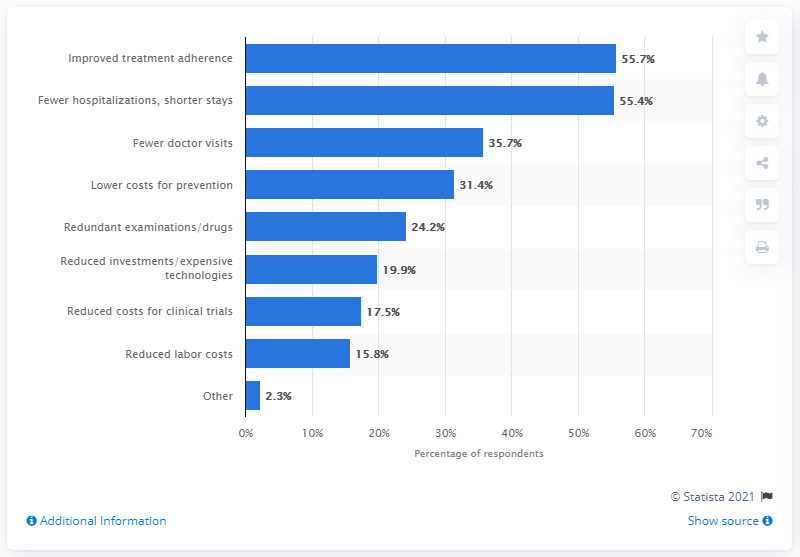Could you explain why reduced labor costs have a lower percentage in terms of potential cost savings? Reduced labor costs are reported at a lower percentage of 15.8% for potential cost savings, possibly because labor expenses might not be perceived as a major factor impacting health care costs directly compared to factors like treatment adherence or hospital stays. 